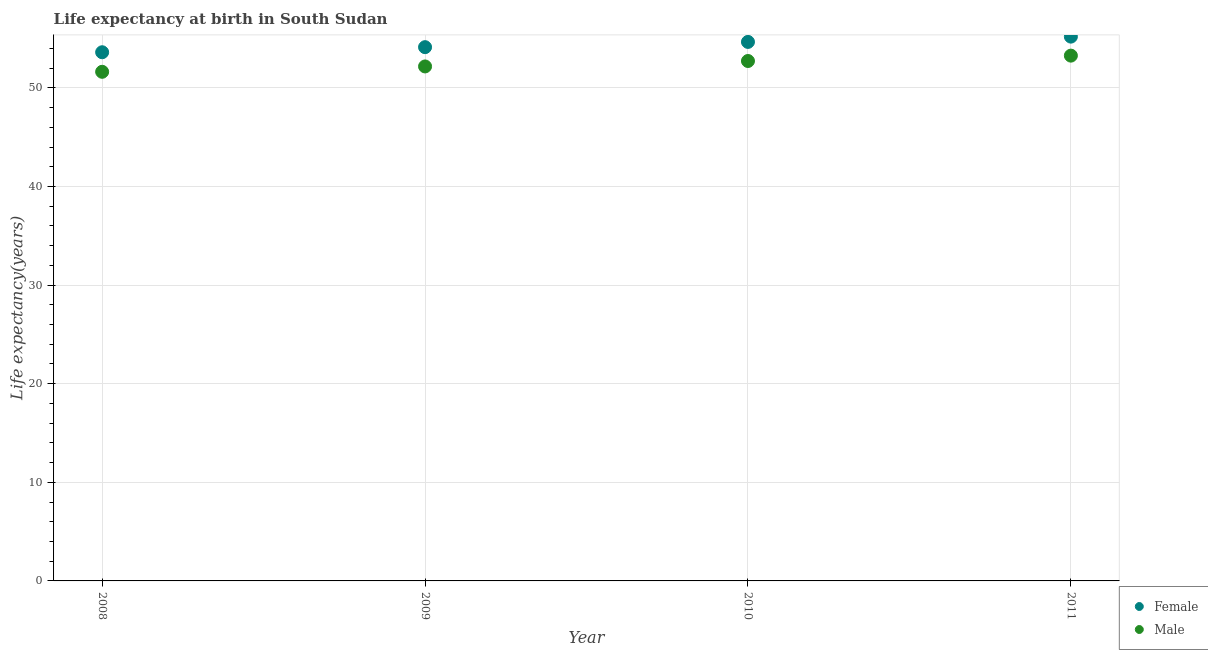What is the life expectancy(male) in 2008?
Ensure brevity in your answer.  51.63. Across all years, what is the maximum life expectancy(female)?
Provide a succinct answer. 55.19. Across all years, what is the minimum life expectancy(male)?
Make the answer very short. 51.63. What is the total life expectancy(female) in the graph?
Provide a short and direct response. 217.58. What is the difference between the life expectancy(female) in 2009 and that in 2011?
Your answer should be very brief. -1.07. What is the difference between the life expectancy(male) in 2011 and the life expectancy(female) in 2008?
Provide a short and direct response. -0.34. What is the average life expectancy(female) per year?
Offer a very short reply. 54.4. In the year 2011, what is the difference between the life expectancy(female) and life expectancy(male)?
Make the answer very short. 1.93. What is the ratio of the life expectancy(male) in 2008 to that in 2011?
Offer a terse response. 0.97. What is the difference between the highest and the second highest life expectancy(male)?
Provide a short and direct response. 0.54. What is the difference between the highest and the lowest life expectancy(male)?
Your answer should be compact. 1.64. In how many years, is the life expectancy(male) greater than the average life expectancy(male) taken over all years?
Provide a succinct answer. 2. Does the life expectancy(female) monotonically increase over the years?
Provide a succinct answer. Yes. Is the life expectancy(male) strictly less than the life expectancy(female) over the years?
Offer a terse response. Yes. How many dotlines are there?
Offer a very short reply. 2. Are the values on the major ticks of Y-axis written in scientific E-notation?
Your answer should be compact. No. Does the graph contain grids?
Ensure brevity in your answer.  Yes. Where does the legend appear in the graph?
Ensure brevity in your answer.  Bottom right. How many legend labels are there?
Your response must be concise. 2. What is the title of the graph?
Keep it short and to the point. Life expectancy at birth in South Sudan. What is the label or title of the X-axis?
Provide a succinct answer. Year. What is the label or title of the Y-axis?
Offer a terse response. Life expectancy(years). What is the Life expectancy(years) in Female in 2008?
Provide a succinct answer. 53.61. What is the Life expectancy(years) in Male in 2008?
Provide a succinct answer. 51.63. What is the Life expectancy(years) in Female in 2009?
Your response must be concise. 54.12. What is the Life expectancy(years) in Male in 2009?
Offer a very short reply. 52.17. What is the Life expectancy(years) of Female in 2010?
Give a very brief answer. 54.66. What is the Life expectancy(years) of Male in 2010?
Your response must be concise. 52.72. What is the Life expectancy(years) in Female in 2011?
Keep it short and to the point. 55.19. What is the Life expectancy(years) in Male in 2011?
Make the answer very short. 53.27. Across all years, what is the maximum Life expectancy(years) of Female?
Ensure brevity in your answer.  55.19. Across all years, what is the maximum Life expectancy(years) in Male?
Provide a short and direct response. 53.27. Across all years, what is the minimum Life expectancy(years) in Female?
Your answer should be very brief. 53.61. Across all years, what is the minimum Life expectancy(years) of Male?
Keep it short and to the point. 51.63. What is the total Life expectancy(years) of Female in the graph?
Offer a very short reply. 217.58. What is the total Life expectancy(years) of Male in the graph?
Give a very brief answer. 209.78. What is the difference between the Life expectancy(years) in Female in 2008 and that in 2009?
Offer a very short reply. -0.52. What is the difference between the Life expectancy(years) in Male in 2008 and that in 2009?
Offer a terse response. -0.54. What is the difference between the Life expectancy(years) in Female in 2008 and that in 2010?
Your answer should be compact. -1.05. What is the difference between the Life expectancy(years) in Male in 2008 and that in 2010?
Your answer should be very brief. -1.09. What is the difference between the Life expectancy(years) of Female in 2008 and that in 2011?
Your answer should be compact. -1.58. What is the difference between the Life expectancy(years) in Male in 2008 and that in 2011?
Provide a short and direct response. -1.64. What is the difference between the Life expectancy(years) of Female in 2009 and that in 2010?
Offer a terse response. -0.53. What is the difference between the Life expectancy(years) in Male in 2009 and that in 2010?
Offer a terse response. -0.55. What is the difference between the Life expectancy(years) of Female in 2009 and that in 2011?
Your answer should be very brief. -1.07. What is the difference between the Life expectancy(years) of Male in 2009 and that in 2011?
Offer a terse response. -1.1. What is the difference between the Life expectancy(years) of Female in 2010 and that in 2011?
Give a very brief answer. -0.54. What is the difference between the Life expectancy(years) of Male in 2010 and that in 2011?
Provide a succinct answer. -0.54. What is the difference between the Life expectancy(years) in Female in 2008 and the Life expectancy(years) in Male in 2009?
Keep it short and to the point. 1.44. What is the difference between the Life expectancy(years) in Female in 2008 and the Life expectancy(years) in Male in 2010?
Your answer should be compact. 0.89. What is the difference between the Life expectancy(years) in Female in 2008 and the Life expectancy(years) in Male in 2011?
Offer a very short reply. 0.34. What is the difference between the Life expectancy(years) in Female in 2009 and the Life expectancy(years) in Male in 2010?
Your answer should be compact. 1.4. What is the difference between the Life expectancy(years) of Female in 2009 and the Life expectancy(years) of Male in 2011?
Your answer should be compact. 0.86. What is the difference between the Life expectancy(years) in Female in 2010 and the Life expectancy(years) in Male in 2011?
Offer a very short reply. 1.39. What is the average Life expectancy(years) in Female per year?
Ensure brevity in your answer.  54.4. What is the average Life expectancy(years) of Male per year?
Keep it short and to the point. 52.45. In the year 2008, what is the difference between the Life expectancy(years) in Female and Life expectancy(years) in Male?
Your answer should be compact. 1.98. In the year 2009, what is the difference between the Life expectancy(years) in Female and Life expectancy(years) in Male?
Provide a succinct answer. 1.96. In the year 2010, what is the difference between the Life expectancy(years) in Female and Life expectancy(years) in Male?
Provide a succinct answer. 1.94. In the year 2011, what is the difference between the Life expectancy(years) in Female and Life expectancy(years) in Male?
Ensure brevity in your answer.  1.93. What is the ratio of the Life expectancy(years) in Male in 2008 to that in 2009?
Offer a terse response. 0.99. What is the ratio of the Life expectancy(years) in Female in 2008 to that in 2010?
Give a very brief answer. 0.98. What is the ratio of the Life expectancy(years) of Male in 2008 to that in 2010?
Provide a succinct answer. 0.98. What is the ratio of the Life expectancy(years) of Female in 2008 to that in 2011?
Your answer should be very brief. 0.97. What is the ratio of the Life expectancy(years) in Male in 2008 to that in 2011?
Provide a short and direct response. 0.97. What is the ratio of the Life expectancy(years) in Female in 2009 to that in 2010?
Your response must be concise. 0.99. What is the ratio of the Life expectancy(years) in Female in 2009 to that in 2011?
Offer a terse response. 0.98. What is the ratio of the Life expectancy(years) of Male in 2009 to that in 2011?
Keep it short and to the point. 0.98. What is the ratio of the Life expectancy(years) in Female in 2010 to that in 2011?
Offer a terse response. 0.99. What is the ratio of the Life expectancy(years) of Male in 2010 to that in 2011?
Your response must be concise. 0.99. What is the difference between the highest and the second highest Life expectancy(years) of Female?
Your answer should be compact. 0.54. What is the difference between the highest and the second highest Life expectancy(years) of Male?
Give a very brief answer. 0.54. What is the difference between the highest and the lowest Life expectancy(years) of Female?
Ensure brevity in your answer.  1.58. What is the difference between the highest and the lowest Life expectancy(years) in Male?
Your response must be concise. 1.64. 